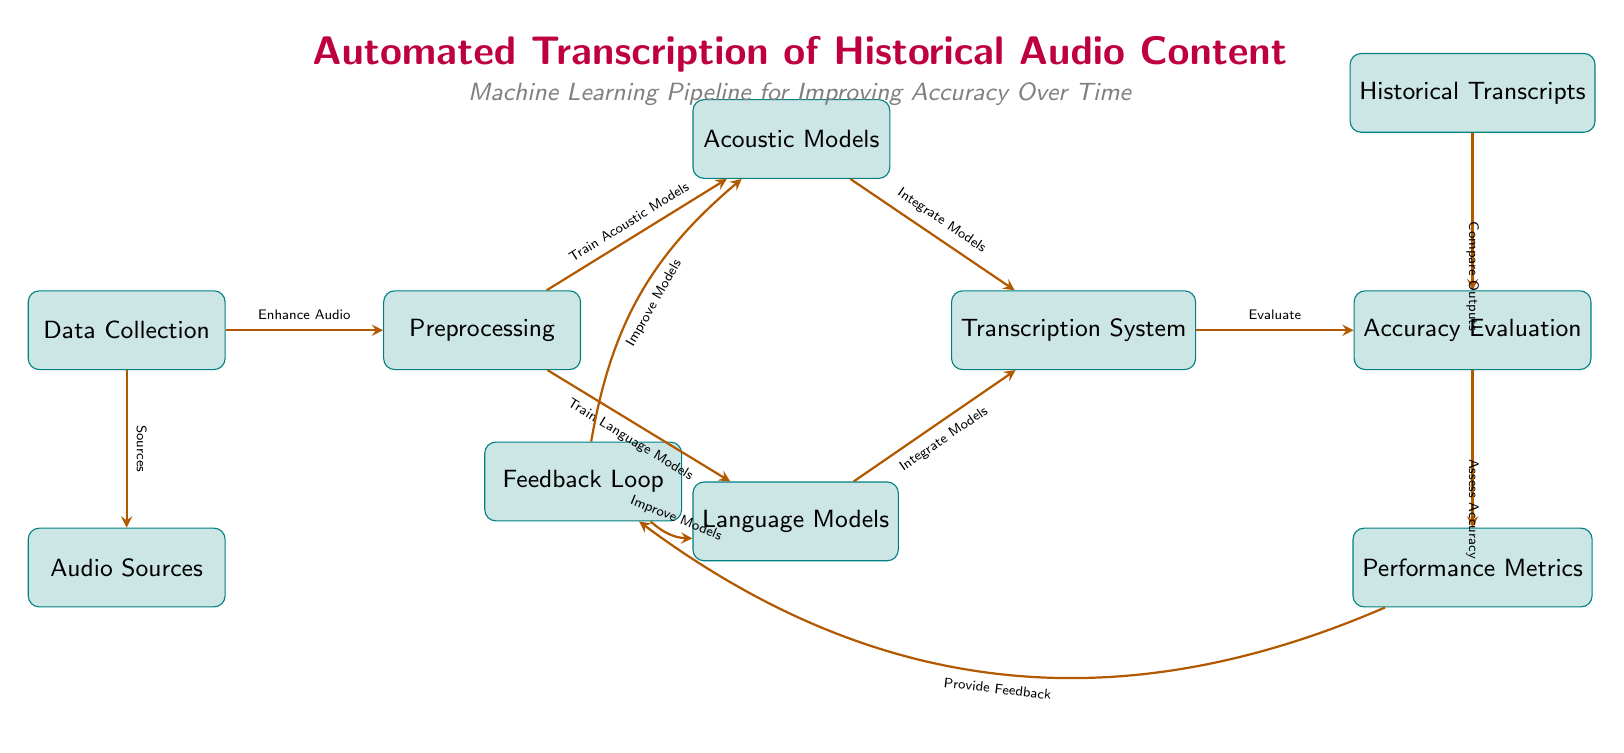What are the two types of models trained after preprocessing? The diagram indicates two types of models that are trained after the preprocessing step, which are listed as "Acoustic Models" and "Language Models". These nodes are directly connected to the preprocessing node on either side.
Answer: Acoustic Models, Language Models How many main components are in the automated transcription process? The diagram displays a total of eight main components: Data Collection, Audio Sources, Preprocessing, Acoustic Models, Language Models, Transcription System, Accuracy Evaluation, and Performance Metrics. The counting involves simply enumerating the nodes that represent these components.
Answer: Eight What process comes immediately after the transcription system? The diagram shows that the process immediately following the transcription system is "Accuracy Evaluation". A direct arrow connects the transcription system to the accuracy evaluation node, indicating the flow of the process.
Answer: Accuracy Evaluation What feedback is provided in the feedback loop? The feedback loop indicates two types of feedback processes: "Improve Models" for both Acoustic Models and Language Models. The diagram explicitly shows these feedback mechanisms directed towards each of the two model types from the performance metrics node.
Answer: Improve Models Which node compares outputs in the accuracy evaluation? The node that is connected for comparison in the accuracy evaluation process is "Historical Transcripts". This connection shows that the historical transcripts are used to assess the accuracy of the transcription outputs.
Answer: Historical Transcripts How does the data collection relate to audio sources? The diagram illustrates a direct relationship where Data Collection provides "Sources" to the Audio Sources node. This reflects that the data collection phase is foundational for gathering the required audio materials.
Answer: Sources What is evaluated to assess accuracy? The diagram specifies that the evaluation involves comparing the outputs from the transcription system with the historical transcripts. This illustrates a comparative assessment to determine the accuracy of the transcriptions.
Answer: Compare Outputs Which components of the systems are integrated in the transcription system? The components integrated into the transcription system are "Acoustic Models" and "Language Models". The arrows in the diagram denote that both types of models feed into this system for transcription purposes.
Answer: Acoustic Models, Language Models What drives the feedback loop improvement? The "Performance Metrics" node drives the feedback loop improvement, indicated by the arrow pointing from performance metrics to the feedback loop, detailing that performance results provide the necessary information to enhance the models.
Answer: Performance Metrics 